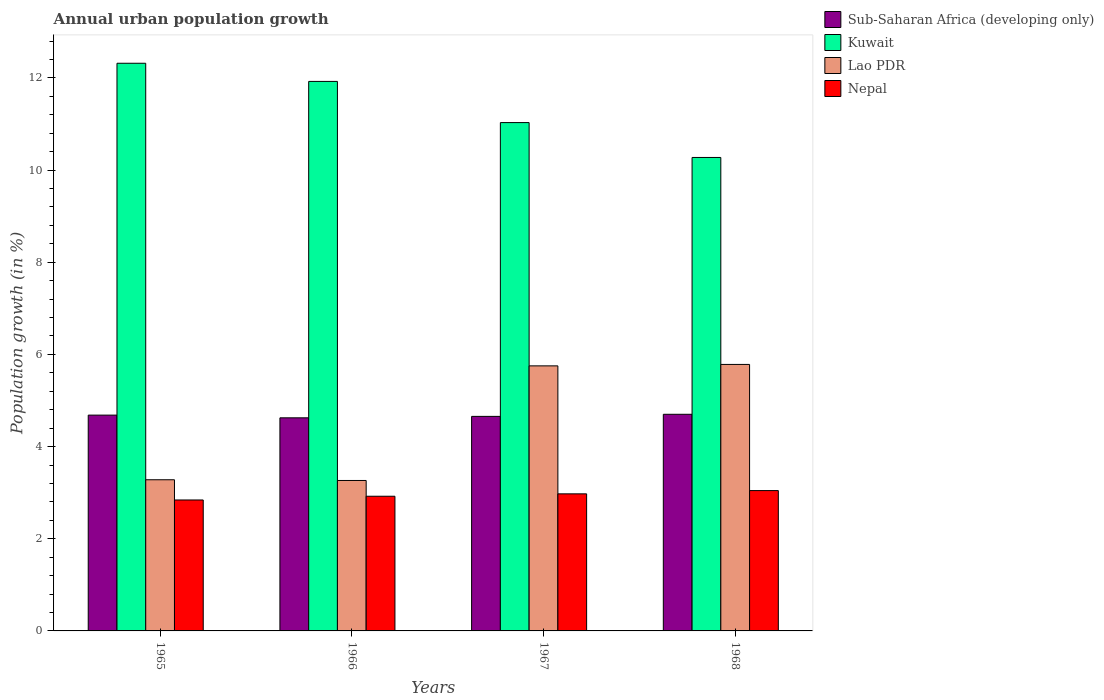How many groups of bars are there?
Make the answer very short. 4. What is the label of the 2nd group of bars from the left?
Your response must be concise. 1966. What is the percentage of urban population growth in Sub-Saharan Africa (developing only) in 1967?
Give a very brief answer. 4.66. Across all years, what is the maximum percentage of urban population growth in Nepal?
Make the answer very short. 3.05. Across all years, what is the minimum percentage of urban population growth in Sub-Saharan Africa (developing only)?
Offer a very short reply. 4.62. In which year was the percentage of urban population growth in Sub-Saharan Africa (developing only) maximum?
Your answer should be compact. 1968. In which year was the percentage of urban population growth in Kuwait minimum?
Make the answer very short. 1968. What is the total percentage of urban population growth in Sub-Saharan Africa (developing only) in the graph?
Ensure brevity in your answer.  18.66. What is the difference between the percentage of urban population growth in Kuwait in 1965 and that in 1966?
Give a very brief answer. 0.39. What is the difference between the percentage of urban population growth in Kuwait in 1968 and the percentage of urban population growth in Lao PDR in 1967?
Offer a terse response. 4.52. What is the average percentage of urban population growth in Nepal per year?
Offer a very short reply. 2.95. In the year 1967, what is the difference between the percentage of urban population growth in Sub-Saharan Africa (developing only) and percentage of urban population growth in Lao PDR?
Your answer should be compact. -1.1. What is the ratio of the percentage of urban population growth in Nepal in 1966 to that in 1968?
Your answer should be very brief. 0.96. Is the difference between the percentage of urban population growth in Sub-Saharan Africa (developing only) in 1966 and 1968 greater than the difference between the percentage of urban population growth in Lao PDR in 1966 and 1968?
Your answer should be compact. Yes. What is the difference between the highest and the second highest percentage of urban population growth in Sub-Saharan Africa (developing only)?
Provide a short and direct response. 0.02. What is the difference between the highest and the lowest percentage of urban population growth in Kuwait?
Your answer should be very brief. 2.04. In how many years, is the percentage of urban population growth in Lao PDR greater than the average percentage of urban population growth in Lao PDR taken over all years?
Offer a very short reply. 2. Is the sum of the percentage of urban population growth in Lao PDR in 1966 and 1968 greater than the maximum percentage of urban population growth in Kuwait across all years?
Offer a terse response. No. What does the 4th bar from the left in 1966 represents?
Offer a terse response. Nepal. What does the 1st bar from the right in 1965 represents?
Keep it short and to the point. Nepal. Is it the case that in every year, the sum of the percentage of urban population growth in Lao PDR and percentage of urban population growth in Sub-Saharan Africa (developing only) is greater than the percentage of urban population growth in Kuwait?
Your answer should be compact. No. Are all the bars in the graph horizontal?
Offer a terse response. No. How many years are there in the graph?
Give a very brief answer. 4. Are the values on the major ticks of Y-axis written in scientific E-notation?
Your response must be concise. No. Does the graph contain any zero values?
Your answer should be very brief. No. How many legend labels are there?
Ensure brevity in your answer.  4. What is the title of the graph?
Make the answer very short. Annual urban population growth. What is the label or title of the X-axis?
Your answer should be very brief. Years. What is the label or title of the Y-axis?
Keep it short and to the point. Population growth (in %). What is the Population growth (in %) of Sub-Saharan Africa (developing only) in 1965?
Offer a terse response. 4.68. What is the Population growth (in %) in Kuwait in 1965?
Offer a terse response. 12.32. What is the Population growth (in %) in Lao PDR in 1965?
Keep it short and to the point. 3.28. What is the Population growth (in %) in Nepal in 1965?
Provide a short and direct response. 2.84. What is the Population growth (in %) of Sub-Saharan Africa (developing only) in 1966?
Offer a very short reply. 4.62. What is the Population growth (in %) in Kuwait in 1966?
Offer a terse response. 11.92. What is the Population growth (in %) of Lao PDR in 1966?
Provide a succinct answer. 3.26. What is the Population growth (in %) in Nepal in 1966?
Provide a short and direct response. 2.92. What is the Population growth (in %) in Sub-Saharan Africa (developing only) in 1967?
Provide a succinct answer. 4.66. What is the Population growth (in %) in Kuwait in 1967?
Keep it short and to the point. 11.03. What is the Population growth (in %) of Lao PDR in 1967?
Offer a terse response. 5.75. What is the Population growth (in %) of Nepal in 1967?
Ensure brevity in your answer.  2.97. What is the Population growth (in %) of Sub-Saharan Africa (developing only) in 1968?
Provide a short and direct response. 4.7. What is the Population growth (in %) of Kuwait in 1968?
Keep it short and to the point. 10.27. What is the Population growth (in %) of Lao PDR in 1968?
Your response must be concise. 5.78. What is the Population growth (in %) in Nepal in 1968?
Your answer should be very brief. 3.05. Across all years, what is the maximum Population growth (in %) of Sub-Saharan Africa (developing only)?
Provide a succinct answer. 4.7. Across all years, what is the maximum Population growth (in %) of Kuwait?
Keep it short and to the point. 12.32. Across all years, what is the maximum Population growth (in %) in Lao PDR?
Make the answer very short. 5.78. Across all years, what is the maximum Population growth (in %) of Nepal?
Ensure brevity in your answer.  3.05. Across all years, what is the minimum Population growth (in %) of Sub-Saharan Africa (developing only)?
Provide a succinct answer. 4.62. Across all years, what is the minimum Population growth (in %) of Kuwait?
Offer a terse response. 10.27. Across all years, what is the minimum Population growth (in %) in Lao PDR?
Provide a succinct answer. 3.26. Across all years, what is the minimum Population growth (in %) in Nepal?
Provide a succinct answer. 2.84. What is the total Population growth (in %) of Sub-Saharan Africa (developing only) in the graph?
Your answer should be compact. 18.66. What is the total Population growth (in %) in Kuwait in the graph?
Give a very brief answer. 45.54. What is the total Population growth (in %) of Lao PDR in the graph?
Your answer should be very brief. 18.08. What is the total Population growth (in %) in Nepal in the graph?
Provide a succinct answer. 11.78. What is the difference between the Population growth (in %) in Sub-Saharan Africa (developing only) in 1965 and that in 1966?
Provide a succinct answer. 0.06. What is the difference between the Population growth (in %) of Kuwait in 1965 and that in 1966?
Ensure brevity in your answer.  0.39. What is the difference between the Population growth (in %) in Lao PDR in 1965 and that in 1966?
Provide a short and direct response. 0.02. What is the difference between the Population growth (in %) in Nepal in 1965 and that in 1966?
Your response must be concise. -0.08. What is the difference between the Population growth (in %) in Sub-Saharan Africa (developing only) in 1965 and that in 1967?
Ensure brevity in your answer.  0.03. What is the difference between the Population growth (in %) of Kuwait in 1965 and that in 1967?
Provide a succinct answer. 1.29. What is the difference between the Population growth (in %) in Lao PDR in 1965 and that in 1967?
Your response must be concise. -2.47. What is the difference between the Population growth (in %) of Nepal in 1965 and that in 1967?
Your answer should be compact. -0.13. What is the difference between the Population growth (in %) of Sub-Saharan Africa (developing only) in 1965 and that in 1968?
Ensure brevity in your answer.  -0.02. What is the difference between the Population growth (in %) in Kuwait in 1965 and that in 1968?
Provide a succinct answer. 2.04. What is the difference between the Population growth (in %) of Lao PDR in 1965 and that in 1968?
Offer a very short reply. -2.5. What is the difference between the Population growth (in %) of Nepal in 1965 and that in 1968?
Your response must be concise. -0.2. What is the difference between the Population growth (in %) in Sub-Saharan Africa (developing only) in 1966 and that in 1967?
Your response must be concise. -0.03. What is the difference between the Population growth (in %) of Kuwait in 1966 and that in 1967?
Your answer should be compact. 0.89. What is the difference between the Population growth (in %) in Lao PDR in 1966 and that in 1967?
Offer a very short reply. -2.49. What is the difference between the Population growth (in %) of Nepal in 1966 and that in 1967?
Your answer should be compact. -0.05. What is the difference between the Population growth (in %) of Sub-Saharan Africa (developing only) in 1966 and that in 1968?
Make the answer very short. -0.08. What is the difference between the Population growth (in %) in Kuwait in 1966 and that in 1968?
Your response must be concise. 1.65. What is the difference between the Population growth (in %) in Lao PDR in 1966 and that in 1968?
Offer a very short reply. -2.52. What is the difference between the Population growth (in %) of Nepal in 1966 and that in 1968?
Offer a terse response. -0.12. What is the difference between the Population growth (in %) in Sub-Saharan Africa (developing only) in 1967 and that in 1968?
Provide a short and direct response. -0.05. What is the difference between the Population growth (in %) of Kuwait in 1967 and that in 1968?
Provide a short and direct response. 0.76. What is the difference between the Population growth (in %) of Lao PDR in 1967 and that in 1968?
Provide a succinct answer. -0.03. What is the difference between the Population growth (in %) in Nepal in 1967 and that in 1968?
Ensure brevity in your answer.  -0.07. What is the difference between the Population growth (in %) of Sub-Saharan Africa (developing only) in 1965 and the Population growth (in %) of Kuwait in 1966?
Offer a terse response. -7.24. What is the difference between the Population growth (in %) of Sub-Saharan Africa (developing only) in 1965 and the Population growth (in %) of Lao PDR in 1966?
Make the answer very short. 1.42. What is the difference between the Population growth (in %) of Sub-Saharan Africa (developing only) in 1965 and the Population growth (in %) of Nepal in 1966?
Ensure brevity in your answer.  1.76. What is the difference between the Population growth (in %) of Kuwait in 1965 and the Population growth (in %) of Lao PDR in 1966?
Your answer should be compact. 9.05. What is the difference between the Population growth (in %) in Kuwait in 1965 and the Population growth (in %) in Nepal in 1966?
Make the answer very short. 9.39. What is the difference between the Population growth (in %) of Lao PDR in 1965 and the Population growth (in %) of Nepal in 1966?
Your response must be concise. 0.36. What is the difference between the Population growth (in %) in Sub-Saharan Africa (developing only) in 1965 and the Population growth (in %) in Kuwait in 1967?
Provide a succinct answer. -6.35. What is the difference between the Population growth (in %) in Sub-Saharan Africa (developing only) in 1965 and the Population growth (in %) in Lao PDR in 1967?
Your answer should be very brief. -1.07. What is the difference between the Population growth (in %) of Sub-Saharan Africa (developing only) in 1965 and the Population growth (in %) of Nepal in 1967?
Your answer should be compact. 1.71. What is the difference between the Population growth (in %) of Kuwait in 1965 and the Population growth (in %) of Lao PDR in 1967?
Provide a succinct answer. 6.57. What is the difference between the Population growth (in %) of Kuwait in 1965 and the Population growth (in %) of Nepal in 1967?
Provide a short and direct response. 9.34. What is the difference between the Population growth (in %) in Lao PDR in 1965 and the Population growth (in %) in Nepal in 1967?
Make the answer very short. 0.31. What is the difference between the Population growth (in %) in Sub-Saharan Africa (developing only) in 1965 and the Population growth (in %) in Kuwait in 1968?
Give a very brief answer. -5.59. What is the difference between the Population growth (in %) in Sub-Saharan Africa (developing only) in 1965 and the Population growth (in %) in Lao PDR in 1968?
Ensure brevity in your answer.  -1.1. What is the difference between the Population growth (in %) of Sub-Saharan Africa (developing only) in 1965 and the Population growth (in %) of Nepal in 1968?
Your response must be concise. 1.64. What is the difference between the Population growth (in %) in Kuwait in 1965 and the Population growth (in %) in Lao PDR in 1968?
Your answer should be very brief. 6.54. What is the difference between the Population growth (in %) of Kuwait in 1965 and the Population growth (in %) of Nepal in 1968?
Offer a very short reply. 9.27. What is the difference between the Population growth (in %) in Lao PDR in 1965 and the Population growth (in %) in Nepal in 1968?
Make the answer very short. 0.23. What is the difference between the Population growth (in %) in Sub-Saharan Africa (developing only) in 1966 and the Population growth (in %) in Kuwait in 1967?
Make the answer very short. -6.41. What is the difference between the Population growth (in %) in Sub-Saharan Africa (developing only) in 1966 and the Population growth (in %) in Lao PDR in 1967?
Your response must be concise. -1.13. What is the difference between the Population growth (in %) of Sub-Saharan Africa (developing only) in 1966 and the Population growth (in %) of Nepal in 1967?
Offer a very short reply. 1.65. What is the difference between the Population growth (in %) in Kuwait in 1966 and the Population growth (in %) in Lao PDR in 1967?
Ensure brevity in your answer.  6.17. What is the difference between the Population growth (in %) in Kuwait in 1966 and the Population growth (in %) in Nepal in 1967?
Your answer should be very brief. 8.95. What is the difference between the Population growth (in %) in Lao PDR in 1966 and the Population growth (in %) in Nepal in 1967?
Your answer should be very brief. 0.29. What is the difference between the Population growth (in %) in Sub-Saharan Africa (developing only) in 1966 and the Population growth (in %) in Kuwait in 1968?
Offer a terse response. -5.65. What is the difference between the Population growth (in %) in Sub-Saharan Africa (developing only) in 1966 and the Population growth (in %) in Lao PDR in 1968?
Provide a succinct answer. -1.16. What is the difference between the Population growth (in %) of Sub-Saharan Africa (developing only) in 1966 and the Population growth (in %) of Nepal in 1968?
Offer a very short reply. 1.58. What is the difference between the Population growth (in %) of Kuwait in 1966 and the Population growth (in %) of Lao PDR in 1968?
Offer a very short reply. 6.14. What is the difference between the Population growth (in %) in Kuwait in 1966 and the Population growth (in %) in Nepal in 1968?
Provide a short and direct response. 8.88. What is the difference between the Population growth (in %) of Lao PDR in 1966 and the Population growth (in %) of Nepal in 1968?
Give a very brief answer. 0.22. What is the difference between the Population growth (in %) of Sub-Saharan Africa (developing only) in 1967 and the Population growth (in %) of Kuwait in 1968?
Keep it short and to the point. -5.62. What is the difference between the Population growth (in %) in Sub-Saharan Africa (developing only) in 1967 and the Population growth (in %) in Lao PDR in 1968?
Your response must be concise. -1.13. What is the difference between the Population growth (in %) in Sub-Saharan Africa (developing only) in 1967 and the Population growth (in %) in Nepal in 1968?
Your response must be concise. 1.61. What is the difference between the Population growth (in %) of Kuwait in 1967 and the Population growth (in %) of Lao PDR in 1968?
Your answer should be compact. 5.25. What is the difference between the Population growth (in %) of Kuwait in 1967 and the Population growth (in %) of Nepal in 1968?
Provide a short and direct response. 7.99. What is the difference between the Population growth (in %) of Lao PDR in 1967 and the Population growth (in %) of Nepal in 1968?
Give a very brief answer. 2.71. What is the average Population growth (in %) in Sub-Saharan Africa (developing only) per year?
Make the answer very short. 4.67. What is the average Population growth (in %) in Kuwait per year?
Your answer should be compact. 11.39. What is the average Population growth (in %) of Lao PDR per year?
Keep it short and to the point. 4.52. What is the average Population growth (in %) in Nepal per year?
Provide a succinct answer. 2.95. In the year 1965, what is the difference between the Population growth (in %) of Sub-Saharan Africa (developing only) and Population growth (in %) of Kuwait?
Provide a succinct answer. -7.63. In the year 1965, what is the difference between the Population growth (in %) in Sub-Saharan Africa (developing only) and Population growth (in %) in Lao PDR?
Ensure brevity in your answer.  1.4. In the year 1965, what is the difference between the Population growth (in %) of Sub-Saharan Africa (developing only) and Population growth (in %) of Nepal?
Ensure brevity in your answer.  1.84. In the year 1965, what is the difference between the Population growth (in %) in Kuwait and Population growth (in %) in Lao PDR?
Offer a very short reply. 9.04. In the year 1965, what is the difference between the Population growth (in %) in Kuwait and Population growth (in %) in Nepal?
Make the answer very short. 9.48. In the year 1965, what is the difference between the Population growth (in %) of Lao PDR and Population growth (in %) of Nepal?
Ensure brevity in your answer.  0.44. In the year 1966, what is the difference between the Population growth (in %) of Sub-Saharan Africa (developing only) and Population growth (in %) of Kuwait?
Your answer should be compact. -7.3. In the year 1966, what is the difference between the Population growth (in %) of Sub-Saharan Africa (developing only) and Population growth (in %) of Lao PDR?
Ensure brevity in your answer.  1.36. In the year 1966, what is the difference between the Population growth (in %) of Sub-Saharan Africa (developing only) and Population growth (in %) of Nepal?
Your answer should be compact. 1.7. In the year 1966, what is the difference between the Population growth (in %) of Kuwait and Population growth (in %) of Lao PDR?
Provide a short and direct response. 8.66. In the year 1966, what is the difference between the Population growth (in %) of Kuwait and Population growth (in %) of Nepal?
Your response must be concise. 9. In the year 1966, what is the difference between the Population growth (in %) of Lao PDR and Population growth (in %) of Nepal?
Your answer should be very brief. 0.34. In the year 1967, what is the difference between the Population growth (in %) in Sub-Saharan Africa (developing only) and Population growth (in %) in Kuwait?
Your answer should be compact. -6.38. In the year 1967, what is the difference between the Population growth (in %) in Sub-Saharan Africa (developing only) and Population growth (in %) in Lao PDR?
Give a very brief answer. -1.1. In the year 1967, what is the difference between the Population growth (in %) of Sub-Saharan Africa (developing only) and Population growth (in %) of Nepal?
Keep it short and to the point. 1.68. In the year 1967, what is the difference between the Population growth (in %) in Kuwait and Population growth (in %) in Lao PDR?
Make the answer very short. 5.28. In the year 1967, what is the difference between the Population growth (in %) of Kuwait and Population growth (in %) of Nepal?
Keep it short and to the point. 8.06. In the year 1967, what is the difference between the Population growth (in %) of Lao PDR and Population growth (in %) of Nepal?
Your response must be concise. 2.78. In the year 1968, what is the difference between the Population growth (in %) in Sub-Saharan Africa (developing only) and Population growth (in %) in Kuwait?
Your response must be concise. -5.57. In the year 1968, what is the difference between the Population growth (in %) of Sub-Saharan Africa (developing only) and Population growth (in %) of Lao PDR?
Make the answer very short. -1.08. In the year 1968, what is the difference between the Population growth (in %) in Sub-Saharan Africa (developing only) and Population growth (in %) in Nepal?
Give a very brief answer. 1.66. In the year 1968, what is the difference between the Population growth (in %) in Kuwait and Population growth (in %) in Lao PDR?
Your answer should be very brief. 4.49. In the year 1968, what is the difference between the Population growth (in %) in Kuwait and Population growth (in %) in Nepal?
Ensure brevity in your answer.  7.23. In the year 1968, what is the difference between the Population growth (in %) in Lao PDR and Population growth (in %) in Nepal?
Provide a succinct answer. 2.74. What is the ratio of the Population growth (in %) of Sub-Saharan Africa (developing only) in 1965 to that in 1966?
Give a very brief answer. 1.01. What is the ratio of the Population growth (in %) in Kuwait in 1965 to that in 1966?
Your answer should be very brief. 1.03. What is the ratio of the Population growth (in %) of Lao PDR in 1965 to that in 1966?
Make the answer very short. 1. What is the ratio of the Population growth (in %) of Nepal in 1965 to that in 1966?
Your response must be concise. 0.97. What is the ratio of the Population growth (in %) of Sub-Saharan Africa (developing only) in 1965 to that in 1967?
Your response must be concise. 1.01. What is the ratio of the Population growth (in %) of Kuwait in 1965 to that in 1967?
Provide a short and direct response. 1.12. What is the ratio of the Population growth (in %) of Lao PDR in 1965 to that in 1967?
Your answer should be compact. 0.57. What is the ratio of the Population growth (in %) in Nepal in 1965 to that in 1967?
Offer a terse response. 0.96. What is the ratio of the Population growth (in %) of Kuwait in 1965 to that in 1968?
Offer a terse response. 1.2. What is the ratio of the Population growth (in %) in Lao PDR in 1965 to that in 1968?
Provide a short and direct response. 0.57. What is the ratio of the Population growth (in %) in Nepal in 1965 to that in 1968?
Ensure brevity in your answer.  0.93. What is the ratio of the Population growth (in %) of Sub-Saharan Africa (developing only) in 1966 to that in 1967?
Your answer should be compact. 0.99. What is the ratio of the Population growth (in %) of Kuwait in 1966 to that in 1967?
Your response must be concise. 1.08. What is the ratio of the Population growth (in %) in Lao PDR in 1966 to that in 1967?
Provide a short and direct response. 0.57. What is the ratio of the Population growth (in %) in Nepal in 1966 to that in 1967?
Provide a succinct answer. 0.98. What is the ratio of the Population growth (in %) in Sub-Saharan Africa (developing only) in 1966 to that in 1968?
Your answer should be compact. 0.98. What is the ratio of the Population growth (in %) in Kuwait in 1966 to that in 1968?
Your response must be concise. 1.16. What is the ratio of the Population growth (in %) of Lao PDR in 1966 to that in 1968?
Make the answer very short. 0.56. What is the ratio of the Population growth (in %) of Nepal in 1966 to that in 1968?
Provide a short and direct response. 0.96. What is the ratio of the Population growth (in %) in Sub-Saharan Africa (developing only) in 1967 to that in 1968?
Make the answer very short. 0.99. What is the ratio of the Population growth (in %) in Kuwait in 1967 to that in 1968?
Your response must be concise. 1.07. What is the ratio of the Population growth (in %) in Nepal in 1967 to that in 1968?
Ensure brevity in your answer.  0.98. What is the difference between the highest and the second highest Population growth (in %) in Sub-Saharan Africa (developing only)?
Offer a terse response. 0.02. What is the difference between the highest and the second highest Population growth (in %) of Kuwait?
Ensure brevity in your answer.  0.39. What is the difference between the highest and the second highest Population growth (in %) in Lao PDR?
Keep it short and to the point. 0.03. What is the difference between the highest and the second highest Population growth (in %) of Nepal?
Your response must be concise. 0.07. What is the difference between the highest and the lowest Population growth (in %) in Sub-Saharan Africa (developing only)?
Ensure brevity in your answer.  0.08. What is the difference between the highest and the lowest Population growth (in %) in Kuwait?
Make the answer very short. 2.04. What is the difference between the highest and the lowest Population growth (in %) in Lao PDR?
Ensure brevity in your answer.  2.52. What is the difference between the highest and the lowest Population growth (in %) in Nepal?
Your answer should be compact. 0.2. 